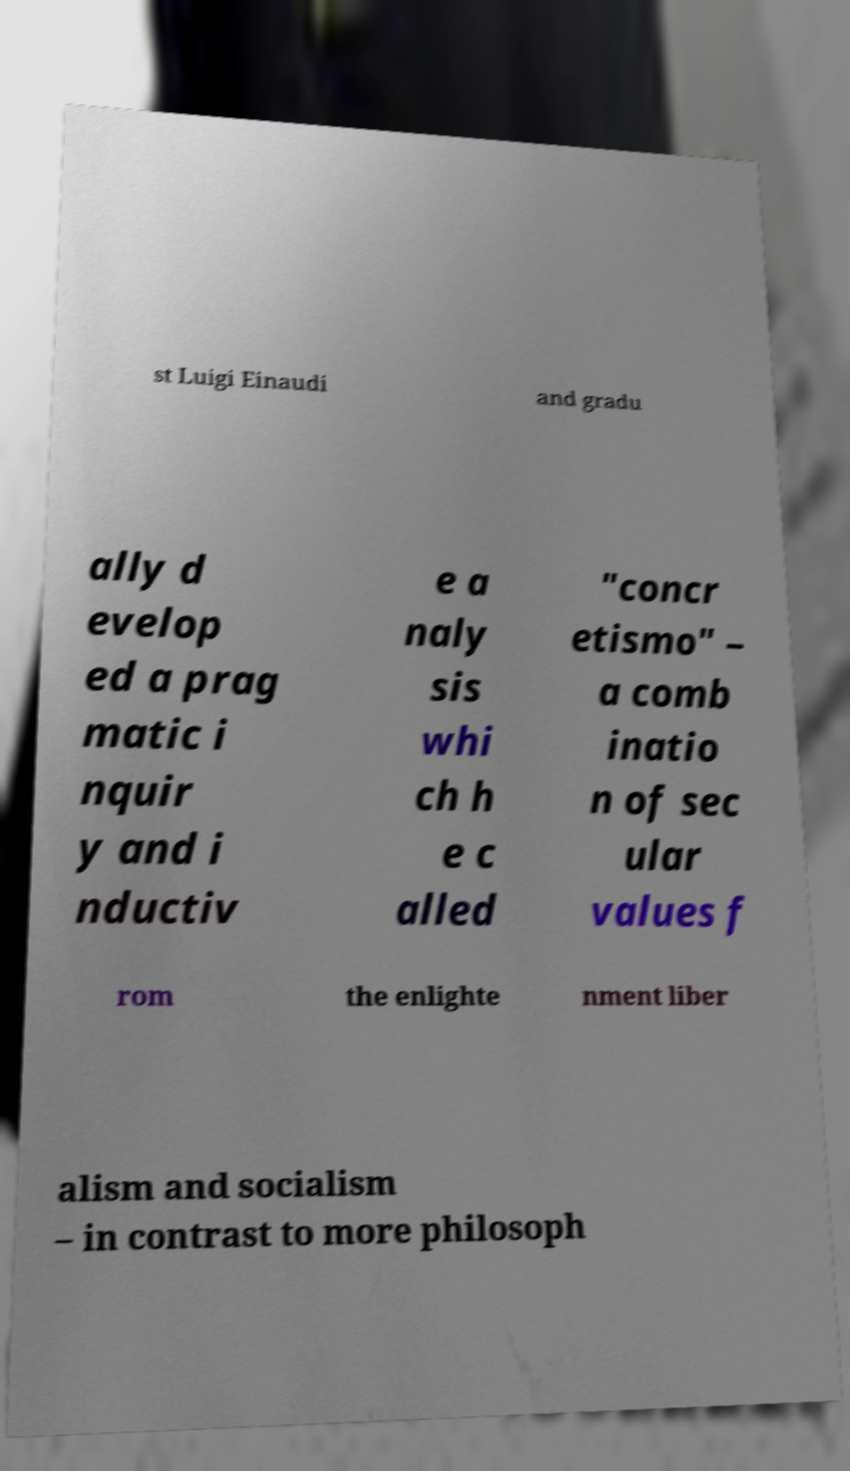For documentation purposes, I need the text within this image transcribed. Could you provide that? st Luigi Einaudi and gradu ally d evelop ed a prag matic i nquir y and i nductiv e a naly sis whi ch h e c alled "concr etismo" – a comb inatio n of sec ular values f rom the enlighte nment liber alism and socialism – in contrast to more philosoph 